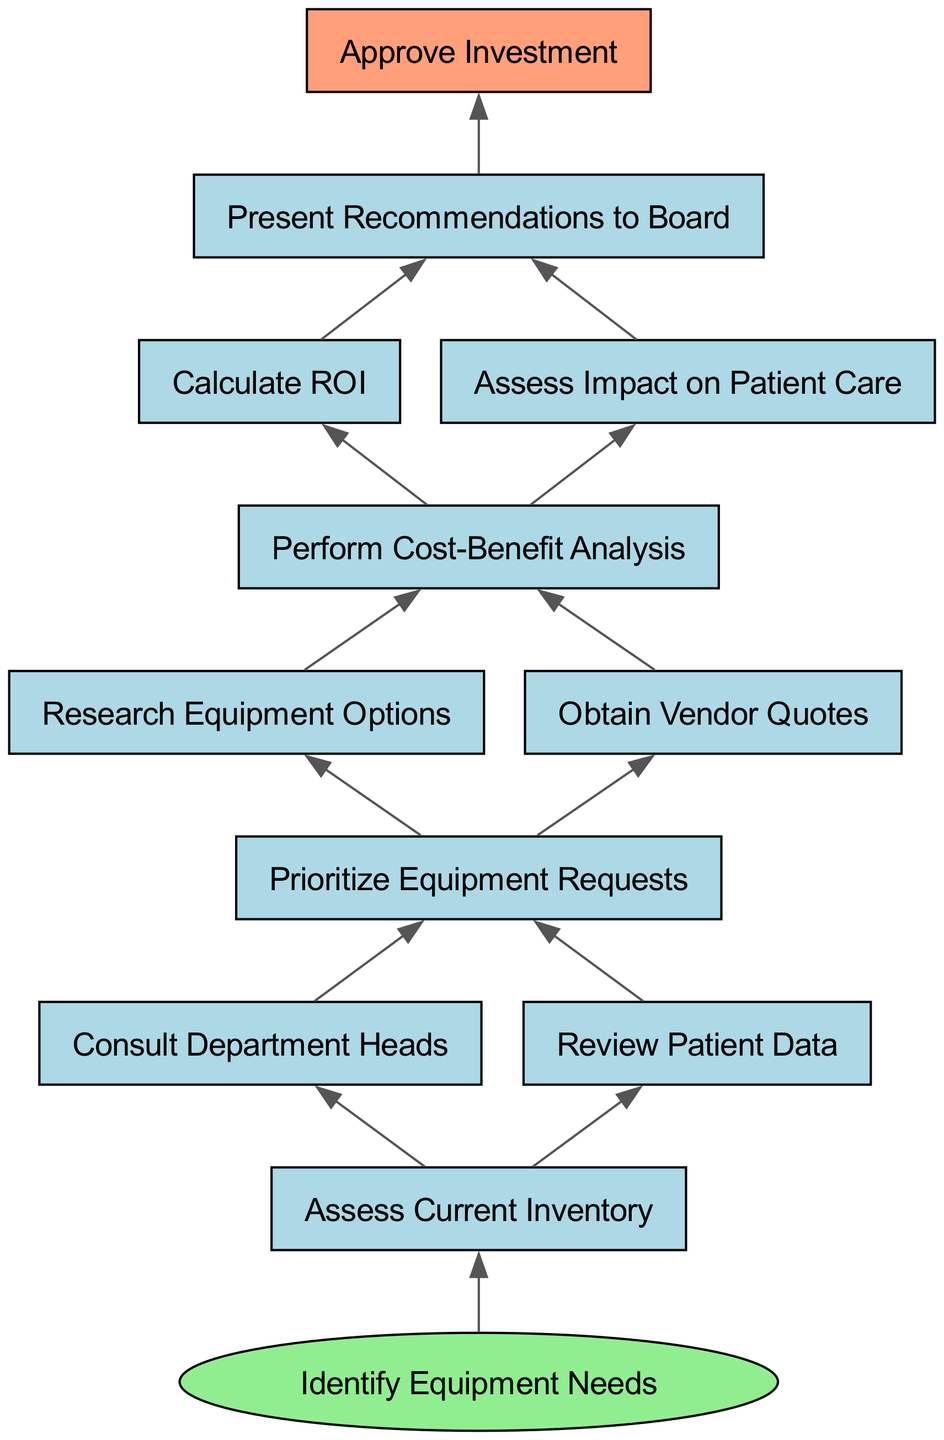What is the starting point of the process? The starting point is indicated by the "Identify Equipment Needs" node, which is the entry point of the diagram. From there, the flow proceeds to the first step, which is "Assess Current Inventory."
Answer: Identify Equipment Needs What is the final step in the process? The final step is identified as "Approve Investment," which is the last node in the flow chart and signifies the completion of the medical equipment acquisition process.
Answer: Approve Investment How many nodes are there in the diagram? By counting the nodes displayed in the diagram, including the starting point and each step, we find a total of 11 nodes.
Answer: 11 What are the two actions that follow "Prioritize Equipment Requests"? After the "Prioritize Equipment Requests" step, the two immediate actions are "Research Equipment Options" and "Obtain Vendor Quotes."
Answer: Research Equipment Options, Obtain Vendor Quotes What is the relationship between "Perform Cost-Benefit Analysis" and "Calculate ROI"? "Perform Cost-Benefit Analysis" directly leads to "Calculate ROI," meaning that completion of the cost-benefit analysis is necessary before calculating the return on investment.
Answer: Directly leads to What step comes after calculating ROI? Following the calculation of ROI, the subsequent step is "Assess Impact on Patient Care," indicating that both assessments are parallel but sequential within the process.
Answer: Assess Impact on Patient Care What is the common outcome of both "Calculate ROI" and "Assess Impact on Patient Care"? Both steps converge at "Present Recommendations to Board," reflecting that findings from both analyses are critical for making a presentation to decision-makers.
Answer: Present Recommendations to Board Which node has the most outgoing edges? "Assess Current Inventory" has two outgoing edges that lead to "Consult Department Heads" and "Review Patient Data," making it the node with the most immediate next steps.
Answer: Assess Current Inventory What comes before "Present Recommendations to Board"? The step preceding "Present Recommendations to Board" is either "Calculate ROI" or "Assess Impact on Patient Care," both of which provide essential data for the presentation.
Answer: Calculate ROI, Assess Impact on Patient Care 